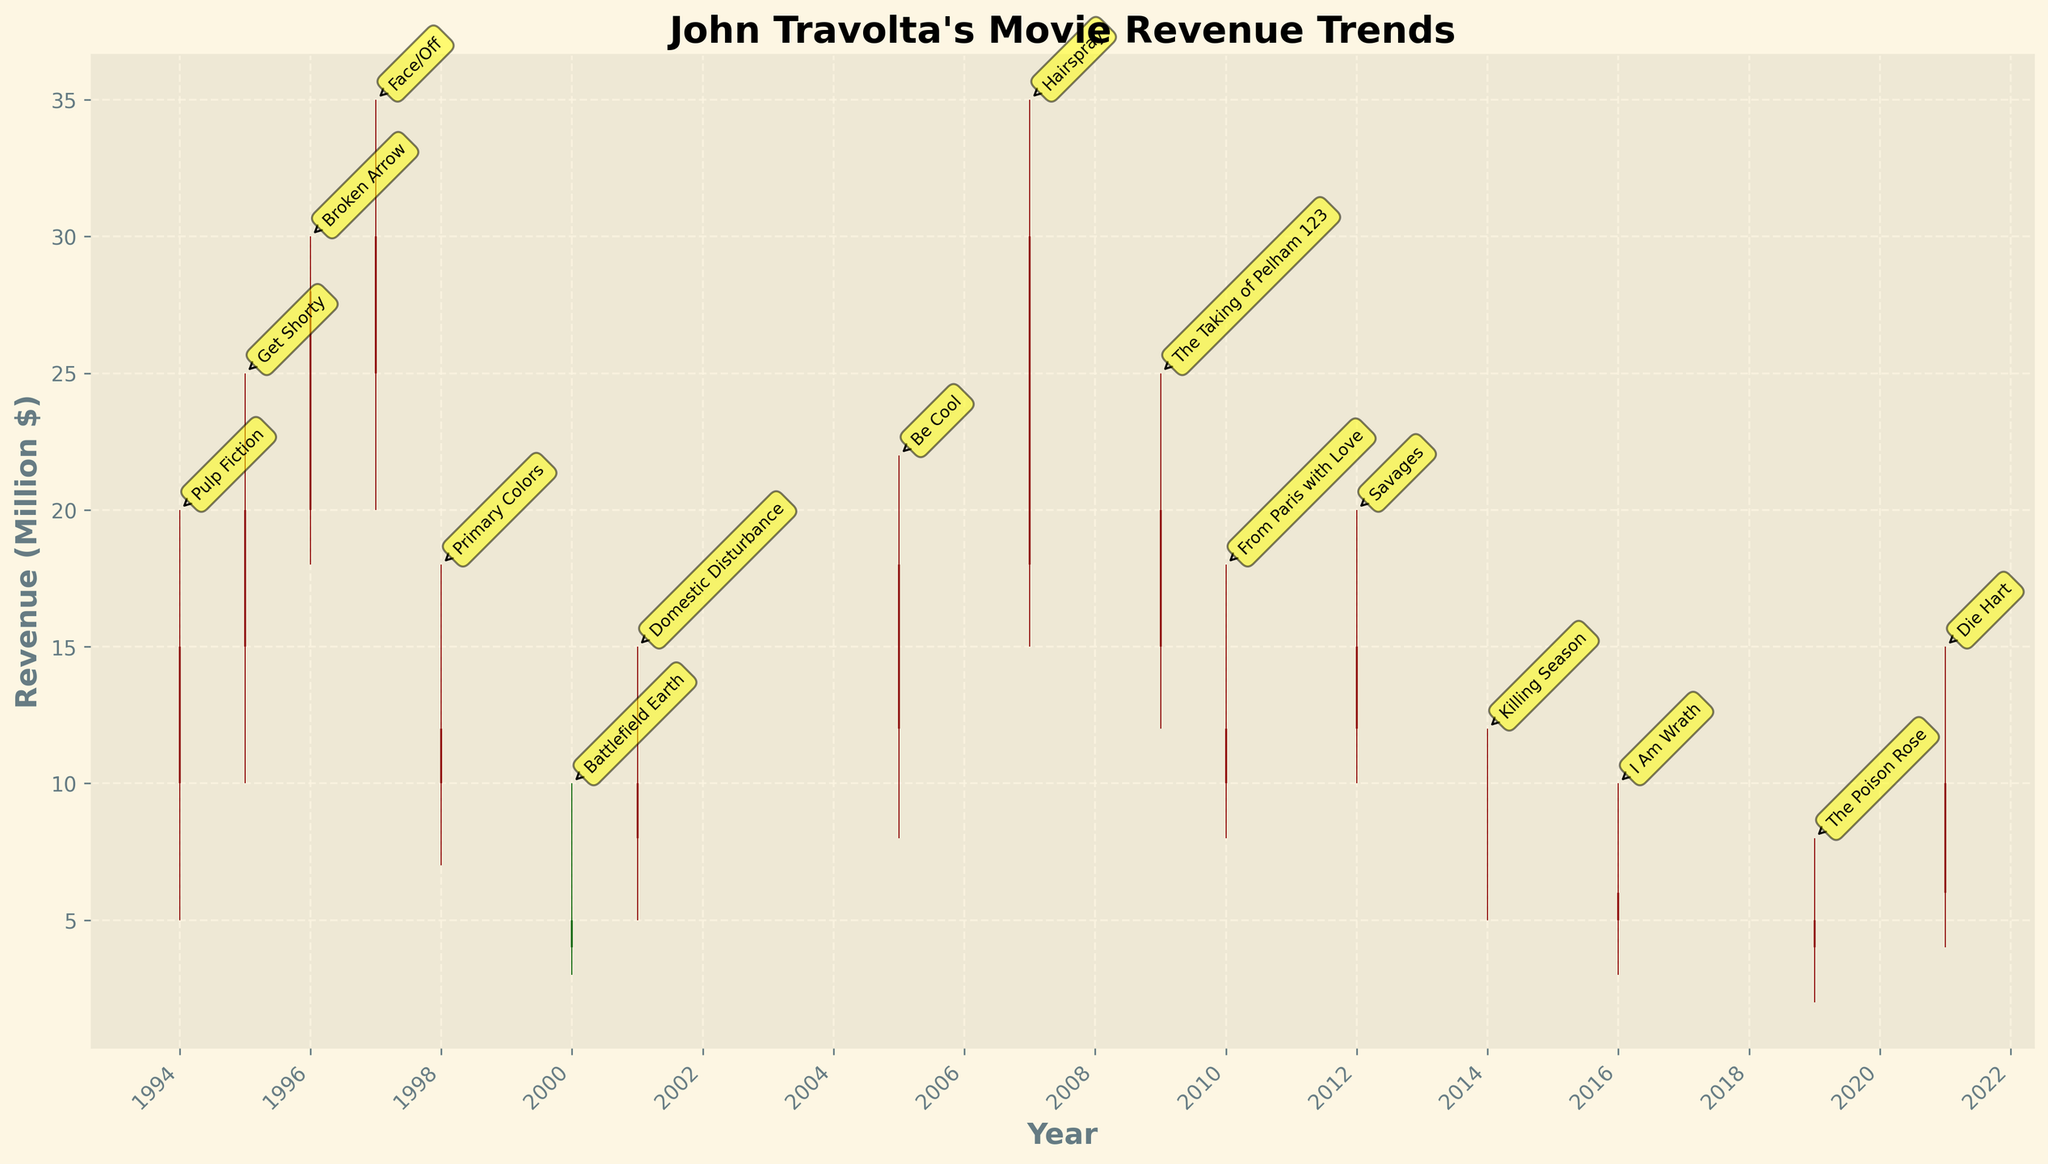What is the title of the plot? The title of the plot is usually at the top of the figure and is written in a larger font, making it easy to identify.
Answer: John Travolta's Movie Revenue Trends Which year had the highest revenue closure among the movies? Look at the closing prices for each candlestick and find the highest value. "Hairspray" in 2007 has the highest closing revenue at $30 million.
Answer: 2007 What is the average closing revenue from 1994 to 1997? Identify the closing revenues from 1994 to 1997, add them up and divide by the number of years: (15 + 20 + 28 + 30)/4 = 93/4 = 23.25.
Answer: 23.25 Which movies had a closing revenue lower than their opening revenue? Check the candlestick where the close is lower than the open. These movies are "Primary Colors", "Battlefield Earth", "From Paris with Love", "Killing Season", "I Am Wrath", and "The Poison Rose".
Answer: 6 movies Which movie had the largest range between its high and low revenue? Calculate the difference between the high and low values for each movie and find the largest difference. "Hairspray" has the largest range of 35 - 15 = 20.
Answer: Hairspray What was the revenue trend for "Battlefield Earth" in 2000? Look at the candlestick for 2000 to determine if the revenue increased or decreased from opening to closing. "Battlefield Earth" showed a decreasing revenue trend from open ($5 million) to close ($4 million).
Answer: Decreasing How many candlesticks are colored green? Candlesticks are green if the closing price is lower than the opening price. Count the green-colored candlesticks. There are 9 of them.
Answer: 9 Which movie had the smallest difference between its opening and closing revenues? Calculate the absolute difference between the opening and closing prices for each movie and identify the smallest one. "Killing Season" had a difference of
Answer: Killing Season What movie in 2021 has its low revenue closest to its high revenue? Check the 2021 candlestick's high and low values. "Die Hart" in 2021 has a high revenue of $15 million and a low revenue of $4 million, making it the closest within the year entries.
Answer: Die Hart 